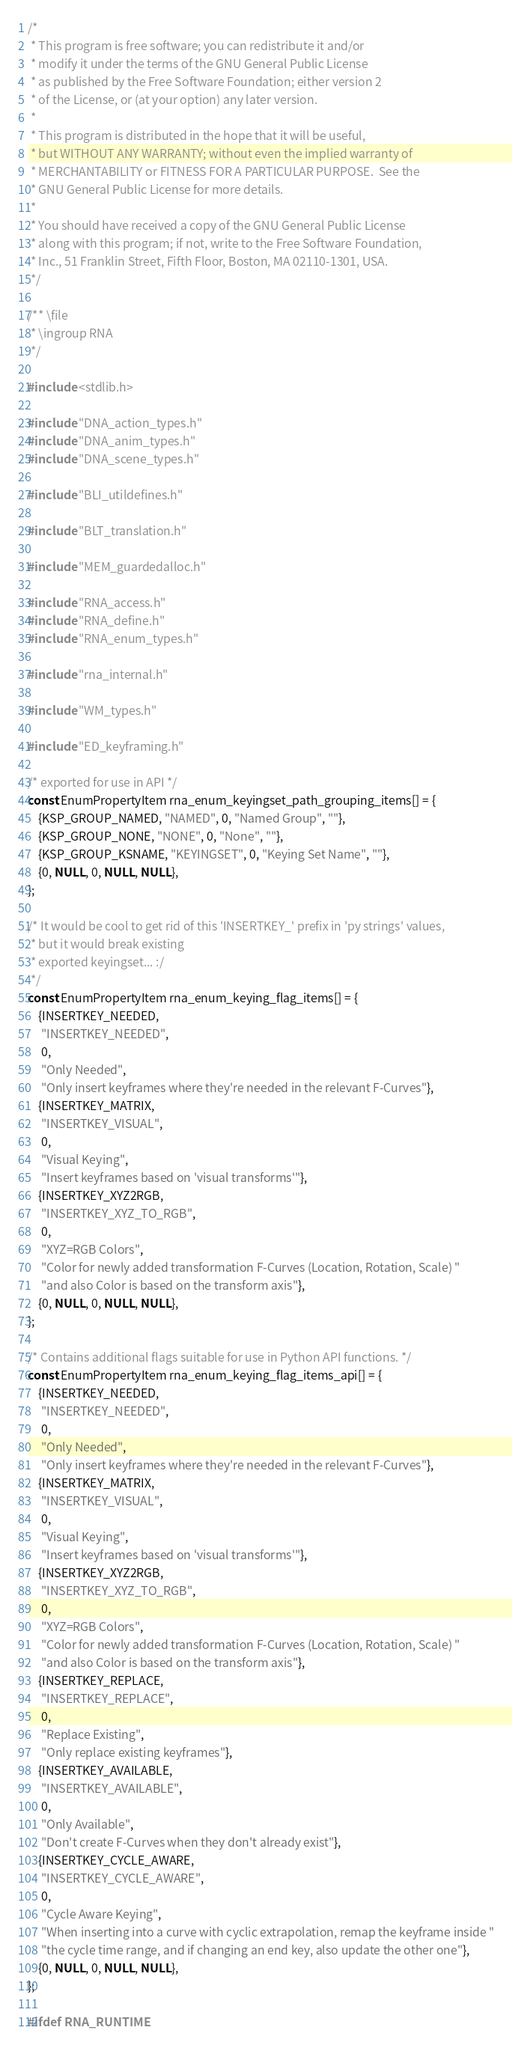<code> <loc_0><loc_0><loc_500><loc_500><_C_>/*
 * This program is free software; you can redistribute it and/or
 * modify it under the terms of the GNU General Public License
 * as published by the Free Software Foundation; either version 2
 * of the License, or (at your option) any later version.
 *
 * This program is distributed in the hope that it will be useful,
 * but WITHOUT ANY WARRANTY; without even the implied warranty of
 * MERCHANTABILITY or FITNESS FOR A PARTICULAR PURPOSE.  See the
 * GNU General Public License for more details.
 *
 * You should have received a copy of the GNU General Public License
 * along with this program; if not, write to the Free Software Foundation,
 * Inc., 51 Franklin Street, Fifth Floor, Boston, MA 02110-1301, USA.
 */

/** \file
 * \ingroup RNA
 */

#include <stdlib.h>

#include "DNA_action_types.h"
#include "DNA_anim_types.h"
#include "DNA_scene_types.h"

#include "BLI_utildefines.h"

#include "BLT_translation.h"

#include "MEM_guardedalloc.h"

#include "RNA_access.h"
#include "RNA_define.h"
#include "RNA_enum_types.h"

#include "rna_internal.h"

#include "WM_types.h"

#include "ED_keyframing.h"

/* exported for use in API */
const EnumPropertyItem rna_enum_keyingset_path_grouping_items[] = {
    {KSP_GROUP_NAMED, "NAMED", 0, "Named Group", ""},
    {KSP_GROUP_NONE, "NONE", 0, "None", ""},
    {KSP_GROUP_KSNAME, "KEYINGSET", 0, "Keying Set Name", ""},
    {0, NULL, 0, NULL, NULL},
};

/* It would be cool to get rid of this 'INSERTKEY_' prefix in 'py strings' values,
 * but it would break existing
 * exported keyingset... :/
 */
const EnumPropertyItem rna_enum_keying_flag_items[] = {
    {INSERTKEY_NEEDED,
     "INSERTKEY_NEEDED",
     0,
     "Only Needed",
     "Only insert keyframes where they're needed in the relevant F-Curves"},
    {INSERTKEY_MATRIX,
     "INSERTKEY_VISUAL",
     0,
     "Visual Keying",
     "Insert keyframes based on 'visual transforms'"},
    {INSERTKEY_XYZ2RGB,
     "INSERTKEY_XYZ_TO_RGB",
     0,
     "XYZ=RGB Colors",
     "Color for newly added transformation F-Curves (Location, Rotation, Scale) "
     "and also Color is based on the transform axis"},
    {0, NULL, 0, NULL, NULL},
};

/* Contains additional flags suitable for use in Python API functions. */
const EnumPropertyItem rna_enum_keying_flag_items_api[] = {
    {INSERTKEY_NEEDED,
     "INSERTKEY_NEEDED",
     0,
     "Only Needed",
     "Only insert keyframes where they're needed in the relevant F-Curves"},
    {INSERTKEY_MATRIX,
     "INSERTKEY_VISUAL",
     0,
     "Visual Keying",
     "Insert keyframes based on 'visual transforms'"},
    {INSERTKEY_XYZ2RGB,
     "INSERTKEY_XYZ_TO_RGB",
     0,
     "XYZ=RGB Colors",
     "Color for newly added transformation F-Curves (Location, Rotation, Scale) "
     "and also Color is based on the transform axis"},
    {INSERTKEY_REPLACE,
     "INSERTKEY_REPLACE",
     0,
     "Replace Existing",
     "Only replace existing keyframes"},
    {INSERTKEY_AVAILABLE,
     "INSERTKEY_AVAILABLE",
     0,
     "Only Available",
     "Don't create F-Curves when they don't already exist"},
    {INSERTKEY_CYCLE_AWARE,
     "INSERTKEY_CYCLE_AWARE",
     0,
     "Cycle Aware Keying",
     "When inserting into a curve with cyclic extrapolation, remap the keyframe inside "
     "the cycle time range, and if changing an end key, also update the other one"},
    {0, NULL, 0, NULL, NULL},
};

#ifdef RNA_RUNTIME
</code> 